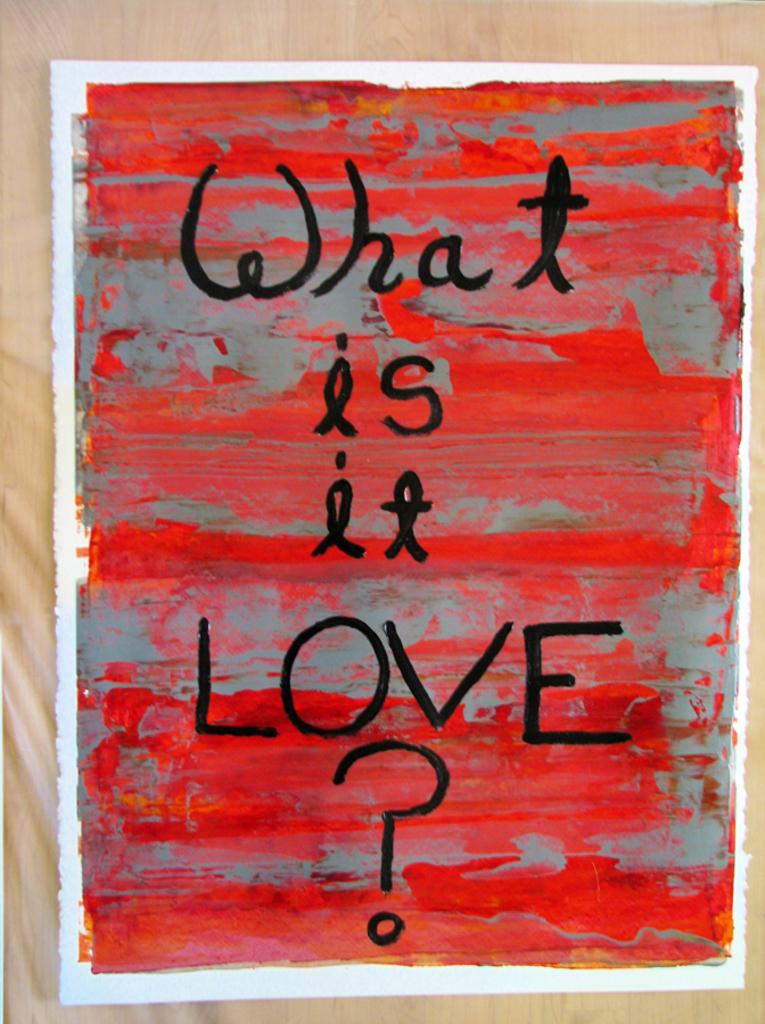What is the main object in the image? There is a board in the image. What is the board placed on? The board is on a wooden surface. What can be seen on the board? There is text on the board. How many sisters are depicted on the board in the image? There are no sisters depicted on the board; it only contains text. What type of house is shown in the background of the image? There is no house present in the image; it only features a board with text on a wooden surface. 